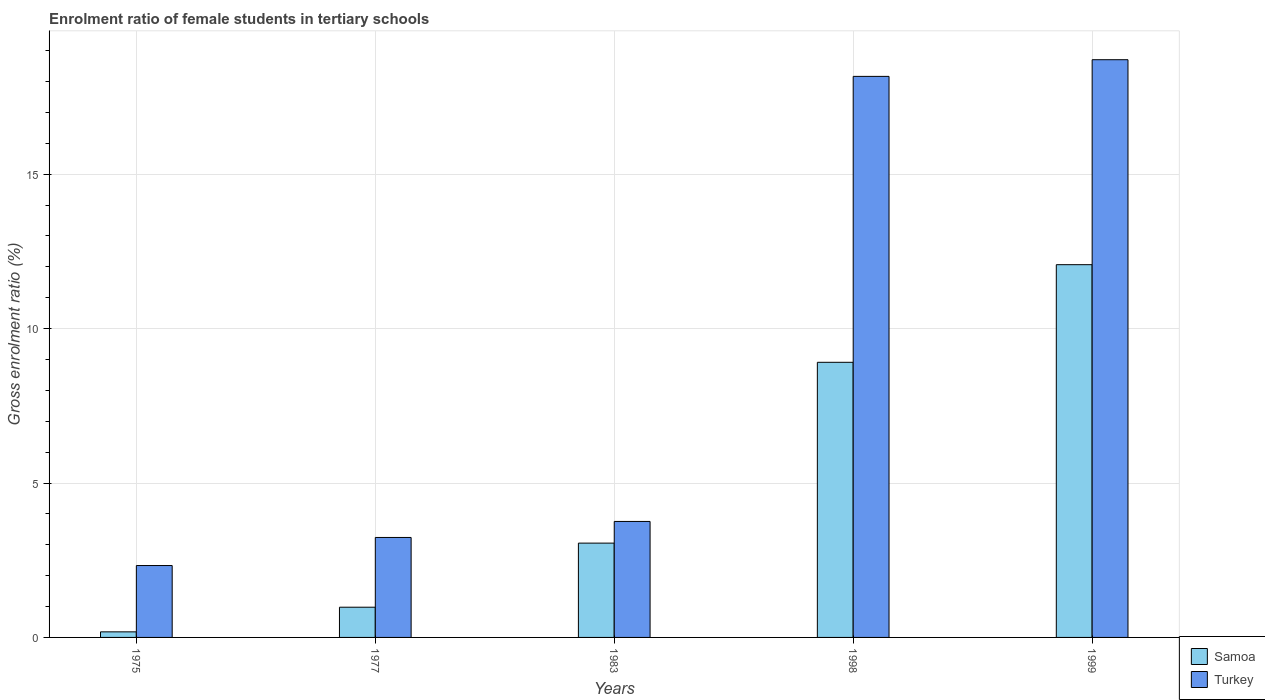Are the number of bars per tick equal to the number of legend labels?
Provide a short and direct response. Yes. Are the number of bars on each tick of the X-axis equal?
Provide a short and direct response. Yes. How many bars are there on the 1st tick from the left?
Give a very brief answer. 2. How many bars are there on the 3rd tick from the right?
Your response must be concise. 2. In how many cases, is the number of bars for a given year not equal to the number of legend labels?
Offer a terse response. 0. What is the enrolment ratio of female students in tertiary schools in Samoa in 1983?
Give a very brief answer. 3.05. Across all years, what is the maximum enrolment ratio of female students in tertiary schools in Samoa?
Keep it short and to the point. 12.07. Across all years, what is the minimum enrolment ratio of female students in tertiary schools in Turkey?
Make the answer very short. 2.33. In which year was the enrolment ratio of female students in tertiary schools in Turkey minimum?
Make the answer very short. 1975. What is the total enrolment ratio of female students in tertiary schools in Samoa in the graph?
Ensure brevity in your answer.  25.19. What is the difference between the enrolment ratio of female students in tertiary schools in Samoa in 1977 and that in 1998?
Provide a short and direct response. -7.93. What is the difference between the enrolment ratio of female students in tertiary schools in Samoa in 1977 and the enrolment ratio of female students in tertiary schools in Turkey in 1998?
Keep it short and to the point. -17.19. What is the average enrolment ratio of female students in tertiary schools in Samoa per year?
Ensure brevity in your answer.  5.04. In the year 1977, what is the difference between the enrolment ratio of female students in tertiary schools in Samoa and enrolment ratio of female students in tertiary schools in Turkey?
Offer a terse response. -2.26. What is the ratio of the enrolment ratio of female students in tertiary schools in Samoa in 1977 to that in 1983?
Offer a terse response. 0.32. What is the difference between the highest and the second highest enrolment ratio of female students in tertiary schools in Samoa?
Ensure brevity in your answer.  3.16. What is the difference between the highest and the lowest enrolment ratio of female students in tertiary schools in Turkey?
Give a very brief answer. 16.38. What does the 2nd bar from the left in 1998 represents?
Your response must be concise. Turkey. What does the 2nd bar from the right in 1977 represents?
Give a very brief answer. Samoa. Are all the bars in the graph horizontal?
Your response must be concise. No. What is the difference between two consecutive major ticks on the Y-axis?
Give a very brief answer. 5. Where does the legend appear in the graph?
Provide a succinct answer. Bottom right. What is the title of the graph?
Offer a very short reply. Enrolment ratio of female students in tertiary schools. What is the Gross enrolment ratio (%) of Samoa in 1975?
Your answer should be very brief. 0.18. What is the Gross enrolment ratio (%) of Turkey in 1975?
Provide a succinct answer. 2.33. What is the Gross enrolment ratio (%) of Samoa in 1977?
Your response must be concise. 0.98. What is the Gross enrolment ratio (%) in Turkey in 1977?
Provide a succinct answer. 3.24. What is the Gross enrolment ratio (%) in Samoa in 1983?
Keep it short and to the point. 3.05. What is the Gross enrolment ratio (%) of Turkey in 1983?
Your answer should be compact. 3.76. What is the Gross enrolment ratio (%) of Samoa in 1998?
Your answer should be very brief. 8.91. What is the Gross enrolment ratio (%) in Turkey in 1998?
Provide a succinct answer. 18.17. What is the Gross enrolment ratio (%) of Samoa in 1999?
Give a very brief answer. 12.07. What is the Gross enrolment ratio (%) of Turkey in 1999?
Make the answer very short. 18.71. Across all years, what is the maximum Gross enrolment ratio (%) of Samoa?
Provide a succinct answer. 12.07. Across all years, what is the maximum Gross enrolment ratio (%) of Turkey?
Ensure brevity in your answer.  18.71. Across all years, what is the minimum Gross enrolment ratio (%) of Samoa?
Give a very brief answer. 0.18. Across all years, what is the minimum Gross enrolment ratio (%) in Turkey?
Your answer should be compact. 2.33. What is the total Gross enrolment ratio (%) of Samoa in the graph?
Provide a short and direct response. 25.19. What is the total Gross enrolment ratio (%) of Turkey in the graph?
Your response must be concise. 46.2. What is the difference between the Gross enrolment ratio (%) of Samoa in 1975 and that in 1977?
Your response must be concise. -0.8. What is the difference between the Gross enrolment ratio (%) of Turkey in 1975 and that in 1977?
Provide a succinct answer. -0.91. What is the difference between the Gross enrolment ratio (%) of Samoa in 1975 and that in 1983?
Provide a short and direct response. -2.87. What is the difference between the Gross enrolment ratio (%) in Turkey in 1975 and that in 1983?
Offer a terse response. -1.43. What is the difference between the Gross enrolment ratio (%) in Samoa in 1975 and that in 1998?
Keep it short and to the point. -8.73. What is the difference between the Gross enrolment ratio (%) in Turkey in 1975 and that in 1998?
Provide a succinct answer. -15.84. What is the difference between the Gross enrolment ratio (%) of Samoa in 1975 and that in 1999?
Offer a terse response. -11.89. What is the difference between the Gross enrolment ratio (%) in Turkey in 1975 and that in 1999?
Your response must be concise. -16.38. What is the difference between the Gross enrolment ratio (%) in Samoa in 1977 and that in 1983?
Your response must be concise. -2.08. What is the difference between the Gross enrolment ratio (%) in Turkey in 1977 and that in 1983?
Give a very brief answer. -0.52. What is the difference between the Gross enrolment ratio (%) of Samoa in 1977 and that in 1998?
Your response must be concise. -7.93. What is the difference between the Gross enrolment ratio (%) of Turkey in 1977 and that in 1998?
Your answer should be compact. -14.93. What is the difference between the Gross enrolment ratio (%) in Samoa in 1977 and that in 1999?
Make the answer very short. -11.09. What is the difference between the Gross enrolment ratio (%) in Turkey in 1977 and that in 1999?
Offer a terse response. -15.47. What is the difference between the Gross enrolment ratio (%) of Samoa in 1983 and that in 1998?
Ensure brevity in your answer.  -5.85. What is the difference between the Gross enrolment ratio (%) of Turkey in 1983 and that in 1998?
Provide a succinct answer. -14.41. What is the difference between the Gross enrolment ratio (%) in Samoa in 1983 and that in 1999?
Keep it short and to the point. -9.02. What is the difference between the Gross enrolment ratio (%) in Turkey in 1983 and that in 1999?
Your answer should be very brief. -14.95. What is the difference between the Gross enrolment ratio (%) of Samoa in 1998 and that in 1999?
Your answer should be very brief. -3.16. What is the difference between the Gross enrolment ratio (%) of Turkey in 1998 and that in 1999?
Provide a succinct answer. -0.54. What is the difference between the Gross enrolment ratio (%) of Samoa in 1975 and the Gross enrolment ratio (%) of Turkey in 1977?
Your answer should be compact. -3.06. What is the difference between the Gross enrolment ratio (%) of Samoa in 1975 and the Gross enrolment ratio (%) of Turkey in 1983?
Offer a terse response. -3.58. What is the difference between the Gross enrolment ratio (%) of Samoa in 1975 and the Gross enrolment ratio (%) of Turkey in 1998?
Keep it short and to the point. -17.99. What is the difference between the Gross enrolment ratio (%) of Samoa in 1975 and the Gross enrolment ratio (%) of Turkey in 1999?
Keep it short and to the point. -18.53. What is the difference between the Gross enrolment ratio (%) in Samoa in 1977 and the Gross enrolment ratio (%) in Turkey in 1983?
Provide a short and direct response. -2.78. What is the difference between the Gross enrolment ratio (%) in Samoa in 1977 and the Gross enrolment ratio (%) in Turkey in 1998?
Your response must be concise. -17.19. What is the difference between the Gross enrolment ratio (%) in Samoa in 1977 and the Gross enrolment ratio (%) in Turkey in 1999?
Give a very brief answer. -17.73. What is the difference between the Gross enrolment ratio (%) in Samoa in 1983 and the Gross enrolment ratio (%) in Turkey in 1998?
Provide a succinct answer. -15.11. What is the difference between the Gross enrolment ratio (%) in Samoa in 1983 and the Gross enrolment ratio (%) in Turkey in 1999?
Your answer should be compact. -15.65. What is the difference between the Gross enrolment ratio (%) of Samoa in 1998 and the Gross enrolment ratio (%) of Turkey in 1999?
Your answer should be compact. -9.8. What is the average Gross enrolment ratio (%) in Samoa per year?
Make the answer very short. 5.04. What is the average Gross enrolment ratio (%) of Turkey per year?
Your response must be concise. 9.24. In the year 1975, what is the difference between the Gross enrolment ratio (%) in Samoa and Gross enrolment ratio (%) in Turkey?
Your answer should be very brief. -2.15. In the year 1977, what is the difference between the Gross enrolment ratio (%) in Samoa and Gross enrolment ratio (%) in Turkey?
Make the answer very short. -2.26. In the year 1983, what is the difference between the Gross enrolment ratio (%) of Samoa and Gross enrolment ratio (%) of Turkey?
Your answer should be compact. -0.7. In the year 1998, what is the difference between the Gross enrolment ratio (%) in Samoa and Gross enrolment ratio (%) in Turkey?
Offer a very short reply. -9.26. In the year 1999, what is the difference between the Gross enrolment ratio (%) in Samoa and Gross enrolment ratio (%) in Turkey?
Provide a short and direct response. -6.64. What is the ratio of the Gross enrolment ratio (%) of Samoa in 1975 to that in 1977?
Your response must be concise. 0.18. What is the ratio of the Gross enrolment ratio (%) in Turkey in 1975 to that in 1977?
Provide a succinct answer. 0.72. What is the ratio of the Gross enrolment ratio (%) of Samoa in 1975 to that in 1983?
Make the answer very short. 0.06. What is the ratio of the Gross enrolment ratio (%) in Turkey in 1975 to that in 1983?
Your answer should be very brief. 0.62. What is the ratio of the Gross enrolment ratio (%) of Samoa in 1975 to that in 1998?
Your answer should be compact. 0.02. What is the ratio of the Gross enrolment ratio (%) of Turkey in 1975 to that in 1998?
Offer a terse response. 0.13. What is the ratio of the Gross enrolment ratio (%) of Samoa in 1975 to that in 1999?
Your answer should be very brief. 0.01. What is the ratio of the Gross enrolment ratio (%) of Turkey in 1975 to that in 1999?
Give a very brief answer. 0.12. What is the ratio of the Gross enrolment ratio (%) of Samoa in 1977 to that in 1983?
Ensure brevity in your answer.  0.32. What is the ratio of the Gross enrolment ratio (%) in Turkey in 1977 to that in 1983?
Your answer should be compact. 0.86. What is the ratio of the Gross enrolment ratio (%) in Samoa in 1977 to that in 1998?
Ensure brevity in your answer.  0.11. What is the ratio of the Gross enrolment ratio (%) of Turkey in 1977 to that in 1998?
Offer a very short reply. 0.18. What is the ratio of the Gross enrolment ratio (%) in Samoa in 1977 to that in 1999?
Make the answer very short. 0.08. What is the ratio of the Gross enrolment ratio (%) in Turkey in 1977 to that in 1999?
Your answer should be very brief. 0.17. What is the ratio of the Gross enrolment ratio (%) of Samoa in 1983 to that in 1998?
Your answer should be compact. 0.34. What is the ratio of the Gross enrolment ratio (%) in Turkey in 1983 to that in 1998?
Provide a short and direct response. 0.21. What is the ratio of the Gross enrolment ratio (%) of Samoa in 1983 to that in 1999?
Provide a short and direct response. 0.25. What is the ratio of the Gross enrolment ratio (%) of Turkey in 1983 to that in 1999?
Keep it short and to the point. 0.2. What is the ratio of the Gross enrolment ratio (%) in Samoa in 1998 to that in 1999?
Offer a terse response. 0.74. What is the ratio of the Gross enrolment ratio (%) in Turkey in 1998 to that in 1999?
Provide a succinct answer. 0.97. What is the difference between the highest and the second highest Gross enrolment ratio (%) in Samoa?
Your answer should be very brief. 3.16. What is the difference between the highest and the second highest Gross enrolment ratio (%) of Turkey?
Provide a succinct answer. 0.54. What is the difference between the highest and the lowest Gross enrolment ratio (%) of Samoa?
Make the answer very short. 11.89. What is the difference between the highest and the lowest Gross enrolment ratio (%) in Turkey?
Your answer should be compact. 16.38. 